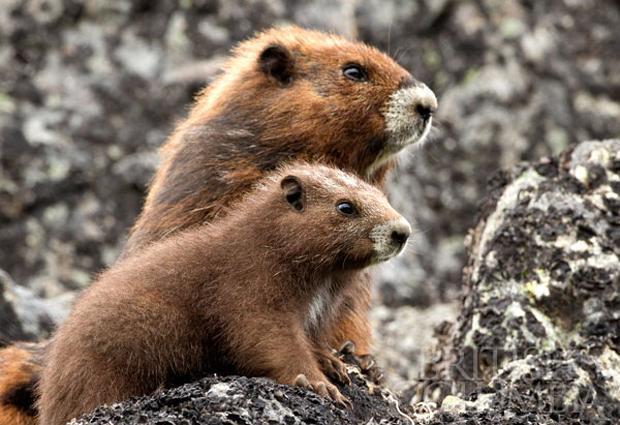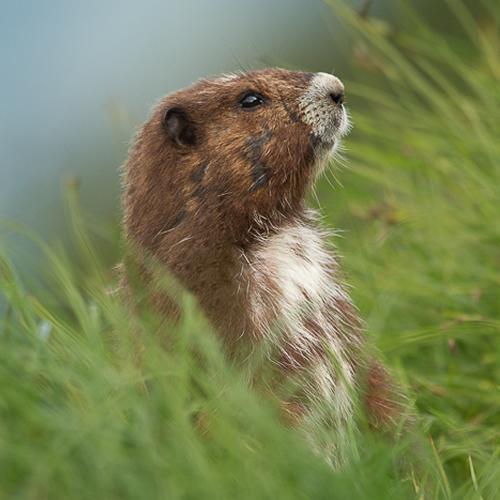The first image is the image on the left, the second image is the image on the right. Considering the images on both sides, is "One image depicts an adult animal and at least one younger rodent." valid? Answer yes or no. Yes. 